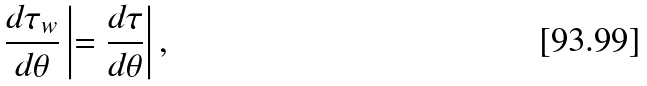Convert formula to latex. <formula><loc_0><loc_0><loc_500><loc_500>\frac { d \tau _ { w } } { d \theta } \left | = \frac { d \tau } { d \theta } \right | ,</formula> 